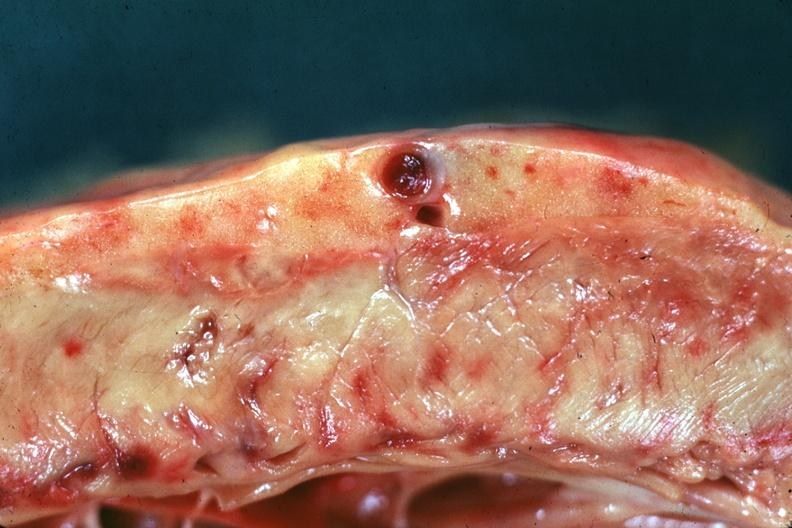s calculi present?
Answer the question using a single word or phrase. Yes 